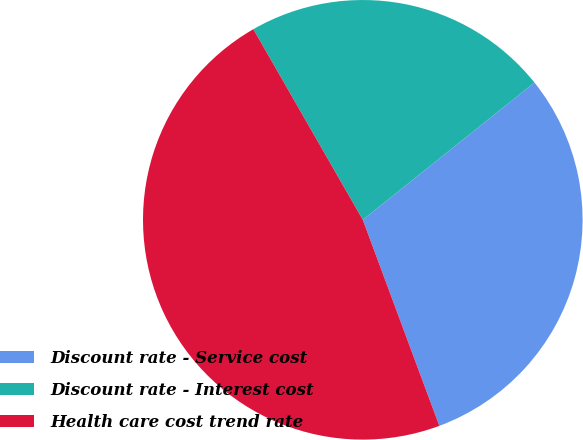Convert chart to OTSL. <chart><loc_0><loc_0><loc_500><loc_500><pie_chart><fcel>Discount rate - Service cost<fcel>Discount rate - Interest cost<fcel>Health care cost trend rate<nl><fcel>30.08%<fcel>22.56%<fcel>47.37%<nl></chart> 